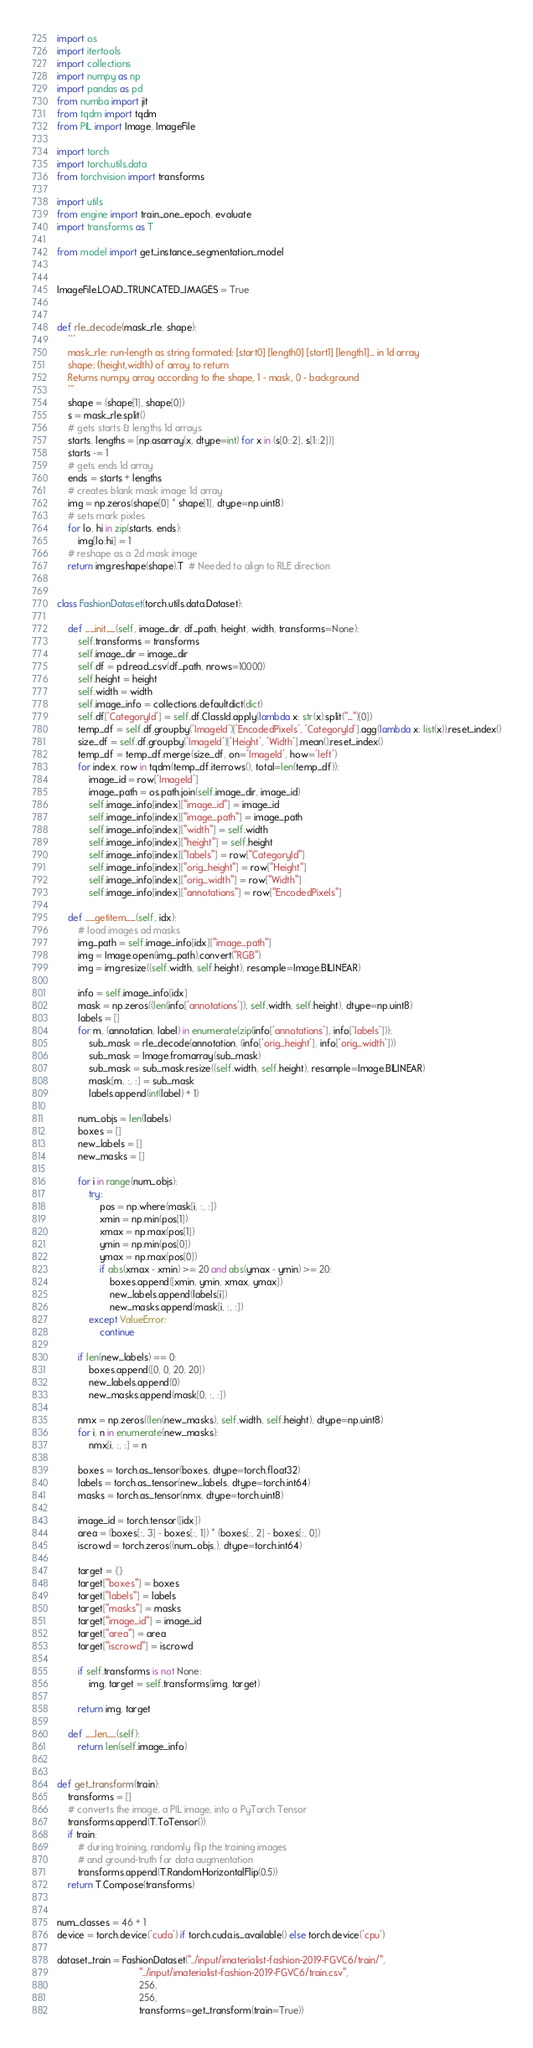<code> <loc_0><loc_0><loc_500><loc_500><_Python_>import os
import itertools
import collections
import numpy as np
import pandas as pd
from numba import jit
from tqdm import tqdm
from PIL import Image, ImageFile

import torch
import torch.utils.data
from torchvision import transforms

import utils
from engine import train_one_epoch, evaluate
import transforms as T

from model import get_instance_segmentation_model


ImageFile.LOAD_TRUNCATED_IMAGES = True


def rle_decode(mask_rle, shape):
    '''
    mask_rle: run-length as string formated: [start0] [length0] [start1] [length1]... in 1d array
    shape: (height,width) of array to return
    Returns numpy array according to the shape, 1 - mask, 0 - background
    '''
    shape = (shape[1], shape[0])
    s = mask_rle.split()
    # gets starts & lengths 1d arrays
    starts, lengths = [np.asarray(x, dtype=int) for x in (s[0::2], s[1::2])]
    starts -= 1
    # gets ends 1d array
    ends = starts + lengths
    # creates blank mask image 1d array
    img = np.zeros(shape[0] * shape[1], dtype=np.uint8)
    # sets mark pixles
    for lo, hi in zip(starts, ends):
        img[lo:hi] = 1
    # reshape as a 2d mask image
    return img.reshape(shape).T  # Needed to align to RLE direction


class FashionDataset(torch.utils.data.Dataset):

    def __init__(self, image_dir, df_path, height, width, transforms=None):
        self.transforms = transforms
        self.image_dir = image_dir
        self.df = pd.read_csv(df_path, nrows=10000)
        self.height = height
        self.width = width
        self.image_info = collections.defaultdict(dict)
        self.df['CategoryId'] = self.df.ClassId.apply(lambda x: str(x).split("_")[0])
        temp_df = self.df.groupby('ImageId')['EncodedPixels', 'CategoryId'].agg(lambda x: list(x)).reset_index()
        size_df = self.df.groupby('ImageId')['Height', 'Width'].mean().reset_index()
        temp_df = temp_df.merge(size_df, on='ImageId', how='left')
        for index, row in tqdm(temp_df.iterrows(), total=len(temp_df)):
            image_id = row['ImageId']
            image_path = os.path.join(self.image_dir, image_id)
            self.image_info[index]["image_id"] = image_id
            self.image_info[index]["image_path"] = image_path
            self.image_info[index]["width"] = self.width
            self.image_info[index]["height"] = self.height
            self.image_info[index]["labels"] = row["CategoryId"]
            self.image_info[index]["orig_height"] = row["Height"]
            self.image_info[index]["orig_width"] = row["Width"]
            self.image_info[index]["annotations"] = row["EncodedPixels"]

    def __getitem__(self, idx):
        # load images ad masks
        img_path = self.image_info[idx]["image_path"]
        img = Image.open(img_path).convert("RGB")
        img = img.resize((self.width, self.height), resample=Image.BILINEAR)

        info = self.image_info[idx]
        mask = np.zeros((len(info['annotations']), self.width, self.height), dtype=np.uint8)
        labels = []
        for m, (annotation, label) in enumerate(zip(info['annotations'], info['labels'])):
            sub_mask = rle_decode(annotation, (info['orig_height'], info['orig_width']))
            sub_mask = Image.fromarray(sub_mask)
            sub_mask = sub_mask.resize((self.width, self.height), resample=Image.BILINEAR)
            mask[m, :, :] = sub_mask
            labels.append(int(label) + 1)

        num_objs = len(labels)
        boxes = []
        new_labels = []
        new_masks = []

        for i in range(num_objs):
            try:
                pos = np.where(mask[i, :, :])
                xmin = np.min(pos[1])
                xmax = np.max(pos[1])
                ymin = np.min(pos[0])
                ymax = np.max(pos[0])
                if abs(xmax - xmin) >= 20 and abs(ymax - ymin) >= 20:
                    boxes.append([xmin, ymin, xmax, ymax])
                    new_labels.append(labels[i])
                    new_masks.append(mask[i, :, :])
            except ValueError:
                continue

        if len(new_labels) == 0:
            boxes.append([0, 0, 20, 20])
            new_labels.append(0)
            new_masks.append(mask[0, :, :])

        nmx = np.zeros((len(new_masks), self.width, self.height), dtype=np.uint8)
        for i, n in enumerate(new_masks):
            nmx[i, :, :] = n

        boxes = torch.as_tensor(boxes, dtype=torch.float32)
        labels = torch.as_tensor(new_labels, dtype=torch.int64)
        masks = torch.as_tensor(nmx, dtype=torch.uint8)

        image_id = torch.tensor([idx])
        area = (boxes[:, 3] - boxes[:, 1]) * (boxes[:, 2] - boxes[:, 0])
        iscrowd = torch.zeros((num_objs,), dtype=torch.int64)

        target = {}
        target["boxes"] = boxes
        target["labels"] = labels
        target["masks"] = masks
        target["image_id"] = image_id
        target["area"] = area
        target["iscrowd"] = iscrowd

        if self.transforms is not None:
            img, target = self.transforms(img, target)

        return img, target

    def __len__(self):
        return len(self.image_info)


def get_transform(train):
    transforms = []
    # converts the image, a PIL image, into a PyTorch Tensor
    transforms.append(T.ToTensor())
    if train:
        # during training, randomly flip the training images
        # and ground-truth for data augmentation
        transforms.append(T.RandomHorizontalFlip(0.5))
    return T.Compose(transforms)


num_classes = 46 + 1
device = torch.device('cuda') if torch.cuda.is_available() else torch.device('cpu')

dataset_train = FashionDataset("../input/imaterialist-fashion-2019-FGVC6/train/",
                               "../input/imaterialist-fashion-2019-FGVC6/train.csv",
                               256,
                               256,
                               transforms=get_transform(train=True))

</code> 